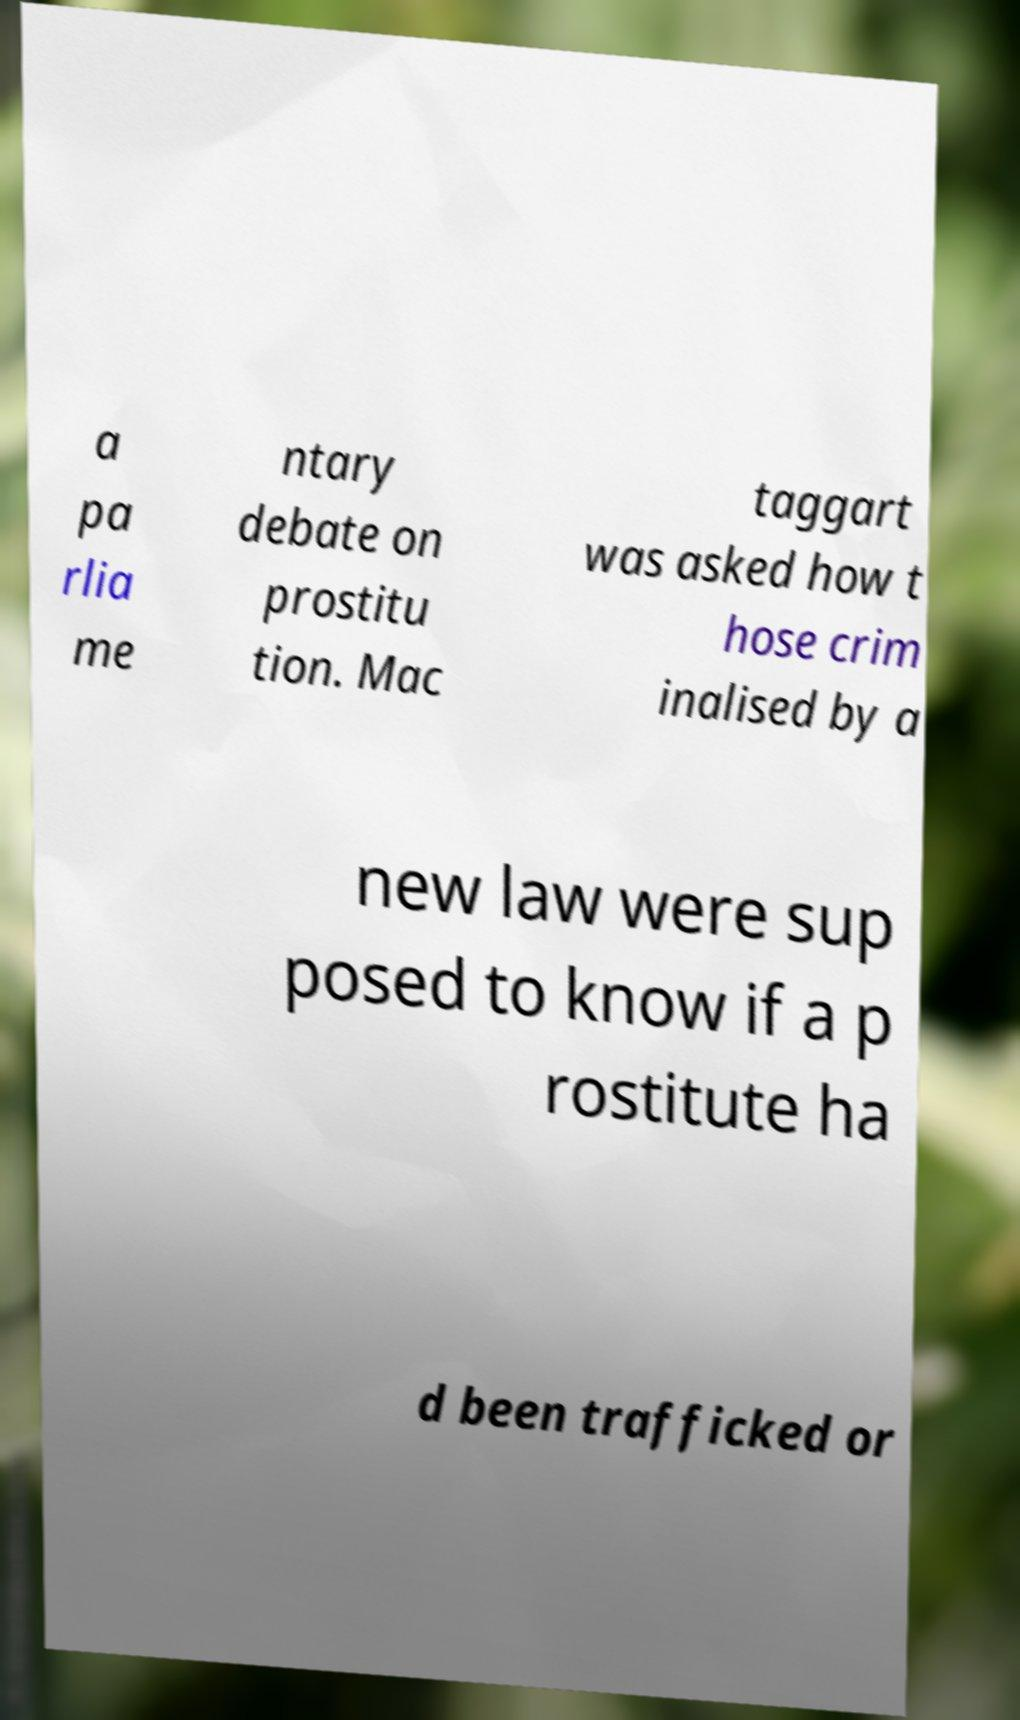Could you assist in decoding the text presented in this image and type it out clearly? a pa rlia me ntary debate on prostitu tion. Mac taggart was asked how t hose crim inalised by a new law were sup posed to know if a p rostitute ha d been trafficked or 